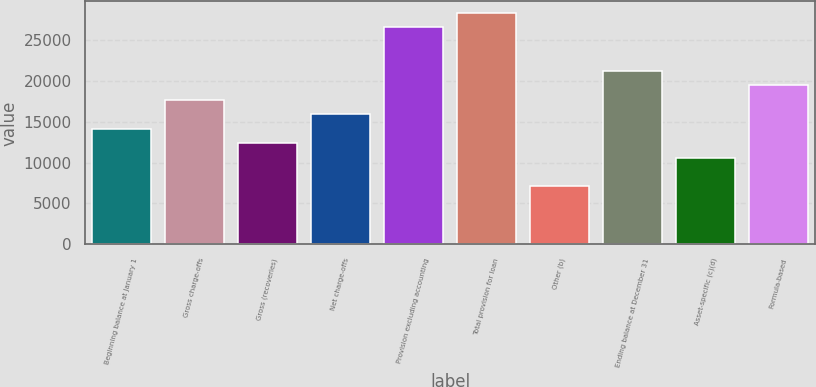Convert chart to OTSL. <chart><loc_0><loc_0><loc_500><loc_500><bar_chart><fcel>Beginning balance at January 1<fcel>Gross charge-offs<fcel>Gross (recoveries)<fcel>Net charge-offs<fcel>Provision excluding accounting<fcel>Total provision for loan<fcel>Other (b)<fcel>Ending balance at December 31<fcel>Asset-specific (c)(d)<fcel>Formula-based<nl><fcel>14161.4<fcel>17701<fcel>12391.5<fcel>15931.2<fcel>26550.2<fcel>28320<fcel>7082.03<fcel>21240.7<fcel>10621.7<fcel>19470.8<nl></chart> 